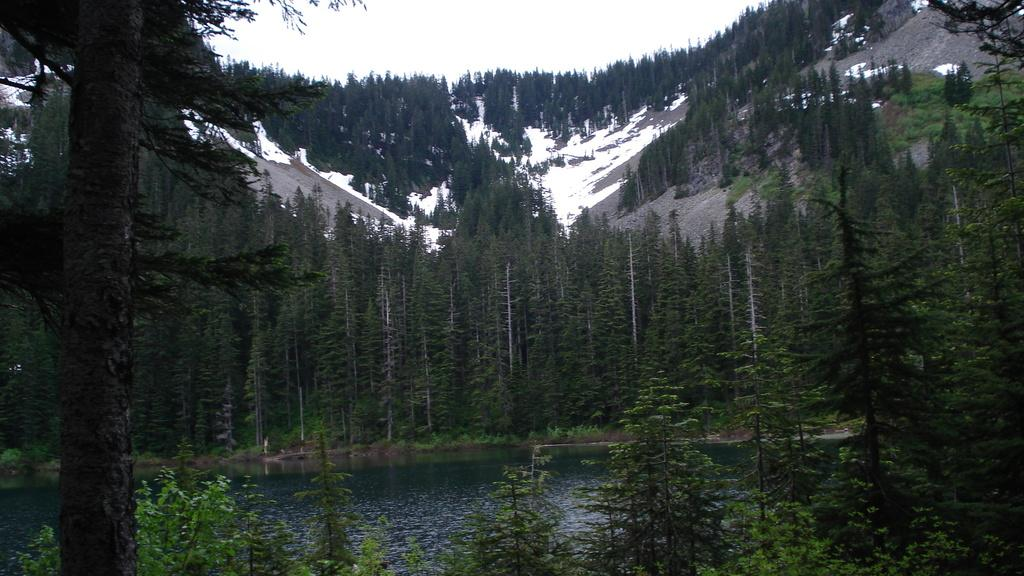What type of natural landscape is depicted in the image? The image features a large group of trees, mountains, and a water body, indicating a natural landscape. Can you describe the terrain in the image? The terrain includes ice, which suggests a cold or snowy environment. What part of a tree can be seen in the image? A bark of a tree is present in the image. What is the condition of the sky in the image? The sky appears cloudy in the image. What type of popcorn is being served at the picnic in the image? There is no picnic or popcorn present in the image; it features a natural landscape with trees, mountains, and a water body. Can you describe the shoes worn by the person in the image? There is no person present in the image, only a natural landscape with trees, mountains, and a water body. 